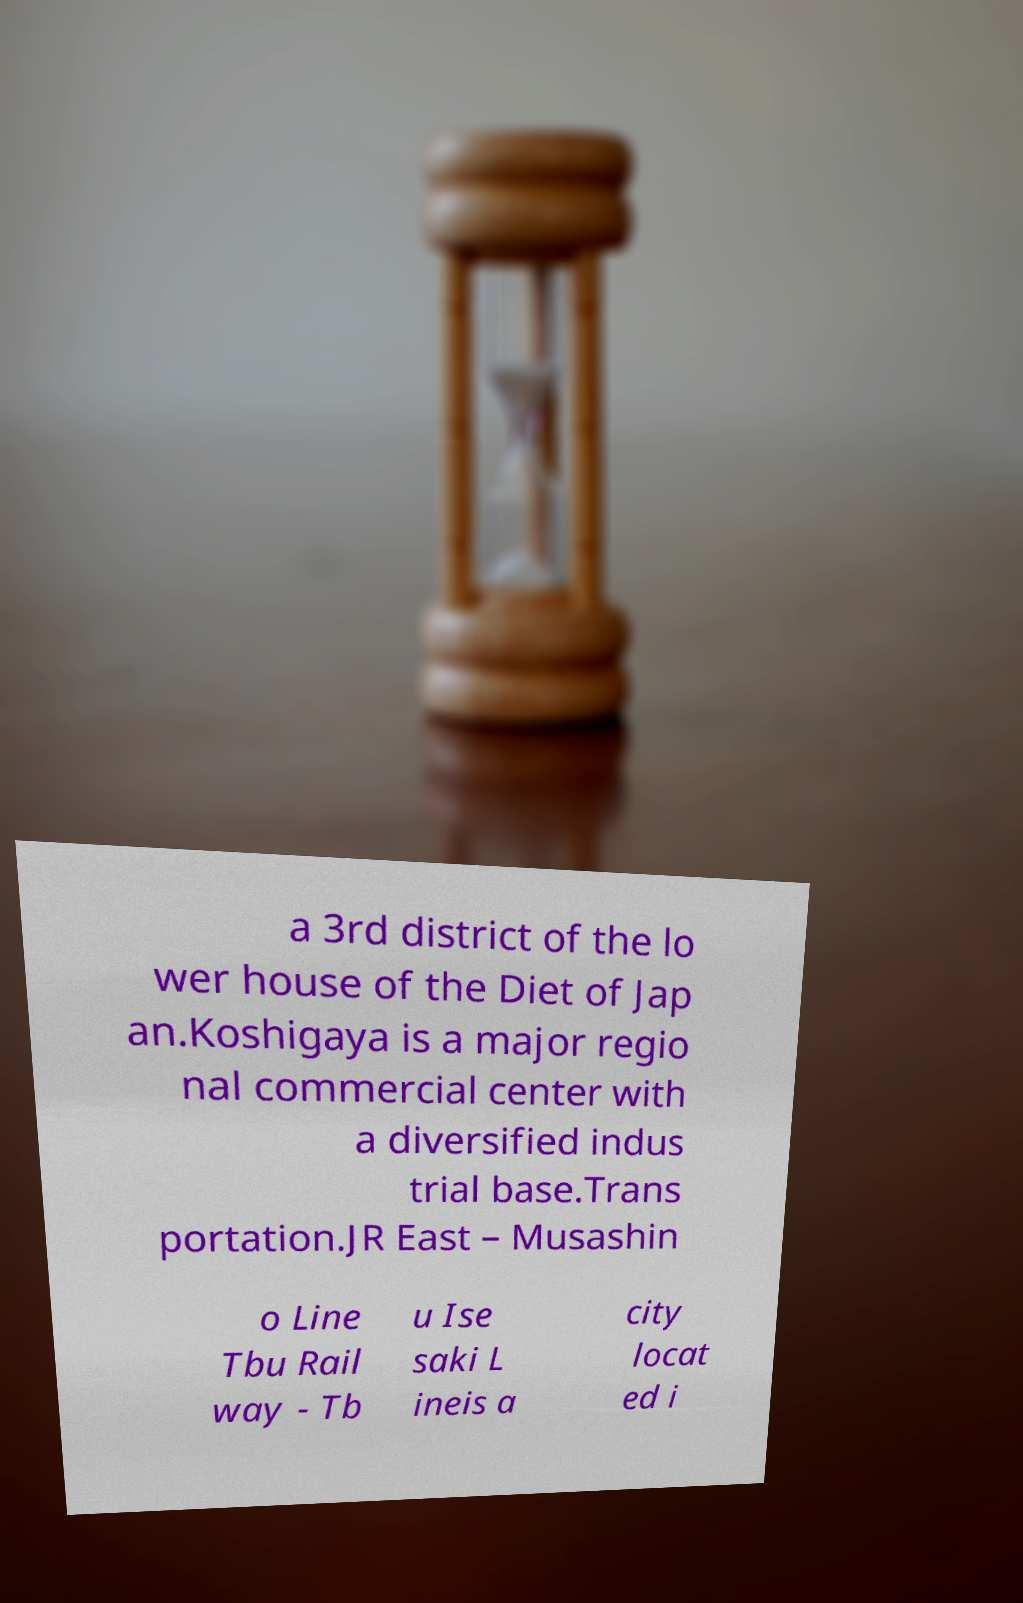Please identify and transcribe the text found in this image. a 3rd district of the lo wer house of the Diet of Jap an.Koshigaya is a major regio nal commercial center with a diversified indus trial base.Trans portation.JR East – Musashin o Line Tbu Rail way - Tb u Ise saki L ineis a city locat ed i 